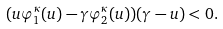<formula> <loc_0><loc_0><loc_500><loc_500>( u \varphi _ { 1 } ^ { \kappa } ( u ) - \gamma \varphi _ { 2 } ^ { \kappa } ( u ) ) ( \gamma - u ) < 0 .</formula> 